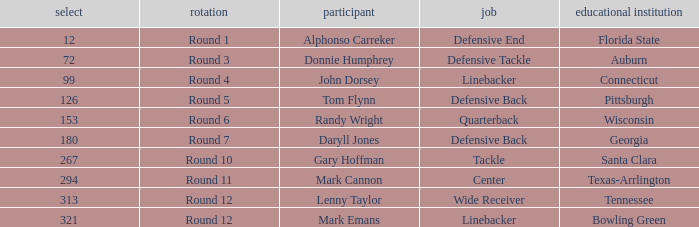What is the Position of Pick #321? Linebacker. 